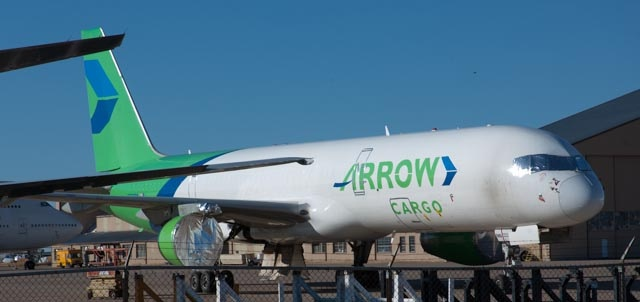Describe the objects in this image and their specific colors. I can see airplane in teal, lightgray, darkgray, black, and gray tones and airplane in teal, darkblue, black, and gray tones in this image. 